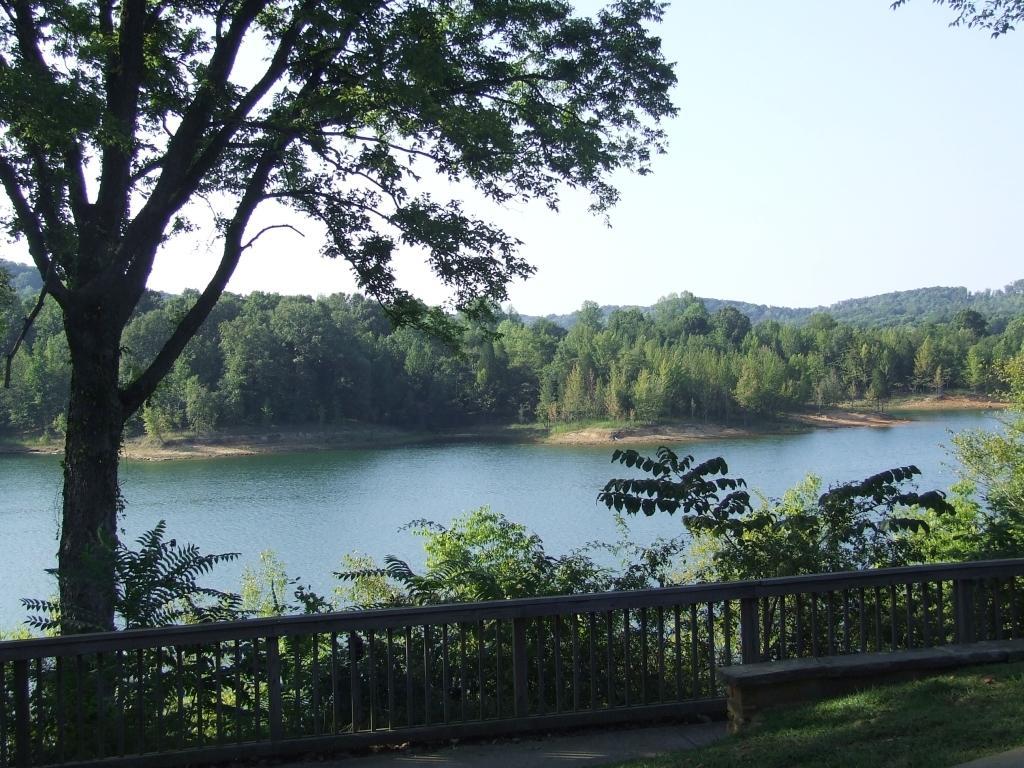How would you summarize this image in a sentence or two? In this image there is green grass at the bottom. There is a metal railing, trees in the foreground. There are trees, water in the background. And there is a sky at the top. 